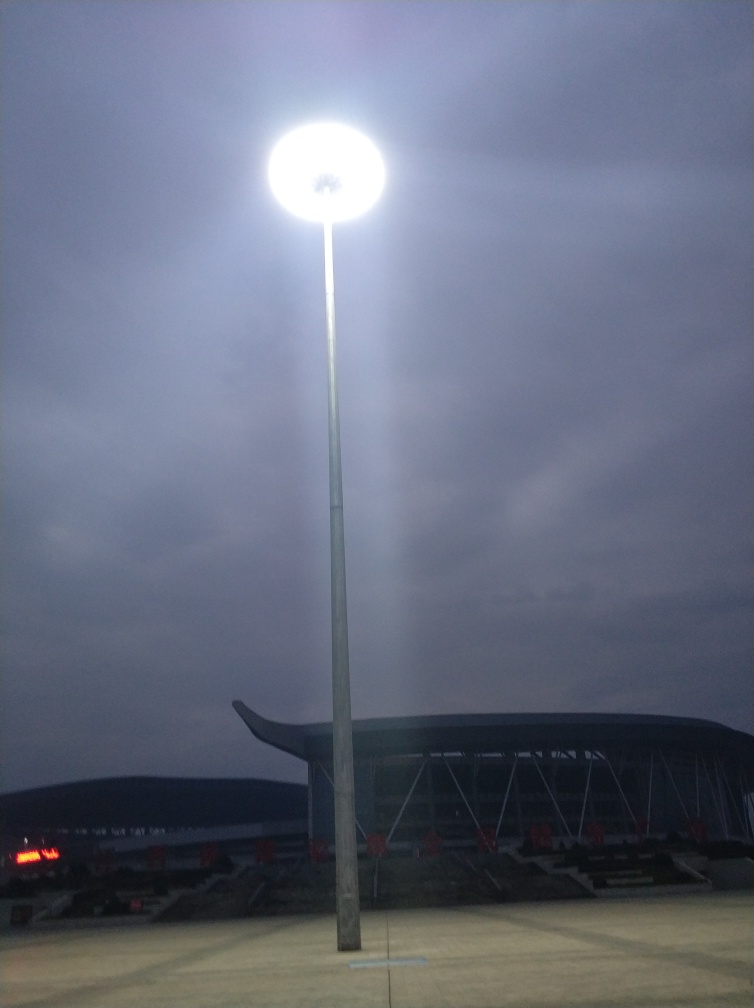What could be the purpose of such a powerful light in this location? The powerful light is likely used to illuminate the sports field for events happening during the evening or night. It ensures clear visibility for players and spectators alike, making it an essential feature for outdoor nighttime sporting events. Could this type of lighting be energy-efficient and sustainable? Energy efficiency for such powerful lights can be achieved through the use of LED technology, which consumes less electricity and has a longer lifespan than traditional bulbs. Sustainable practices might also involve using sensors or timers to ensure the lights are only on when necessary, further reducing energy consumption. 